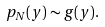<formula> <loc_0><loc_0><loc_500><loc_500>p _ { N } ( y ) \sim g ( y ) .</formula> 